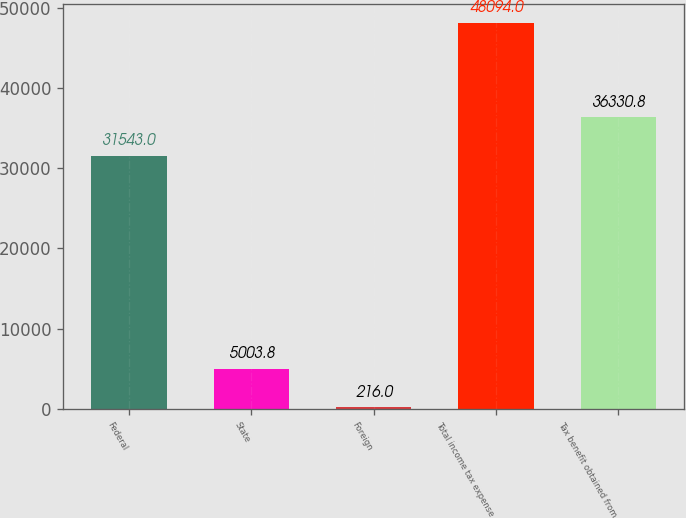<chart> <loc_0><loc_0><loc_500><loc_500><bar_chart><fcel>Federal<fcel>State<fcel>Foreign<fcel>Total income tax expense<fcel>Tax benefit obtained from<nl><fcel>31543<fcel>5003.8<fcel>216<fcel>48094<fcel>36330.8<nl></chart> 